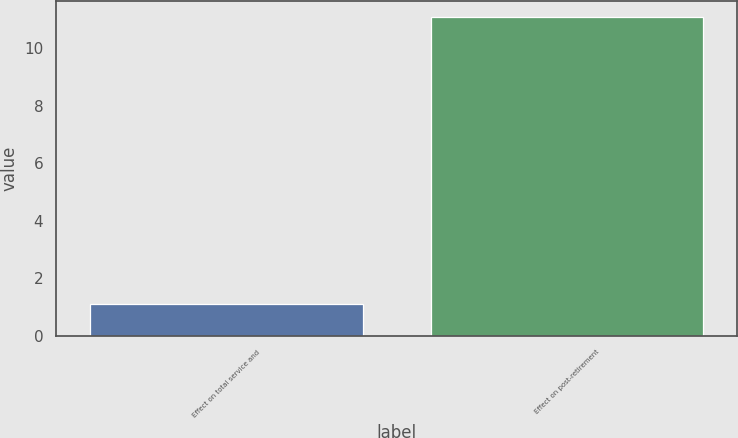Convert chart to OTSL. <chart><loc_0><loc_0><loc_500><loc_500><bar_chart><fcel>Effect on total service and<fcel>Effect on post-retirement<nl><fcel>1.1<fcel>11.1<nl></chart> 